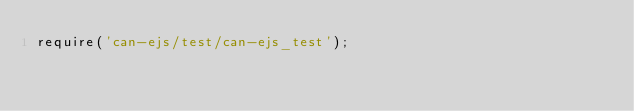<code> <loc_0><loc_0><loc_500><loc_500><_JavaScript_>require('can-ejs/test/can-ejs_test');
</code> 